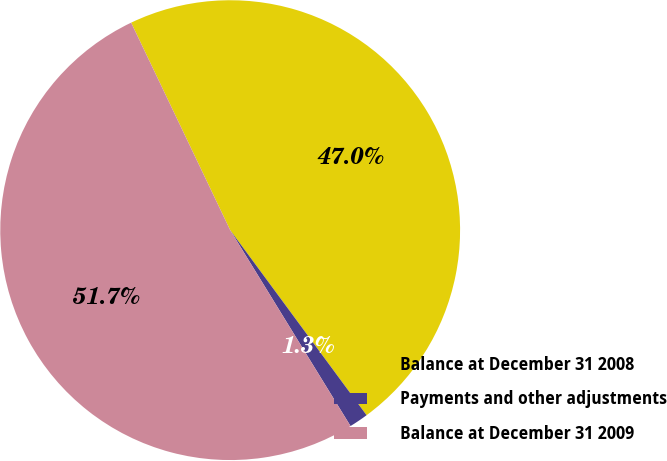<chart> <loc_0><loc_0><loc_500><loc_500><pie_chart><fcel>Balance at December 31 2008<fcel>Payments and other adjustments<fcel>Balance at December 31 2009<nl><fcel>46.98%<fcel>1.34%<fcel>51.68%<nl></chart> 